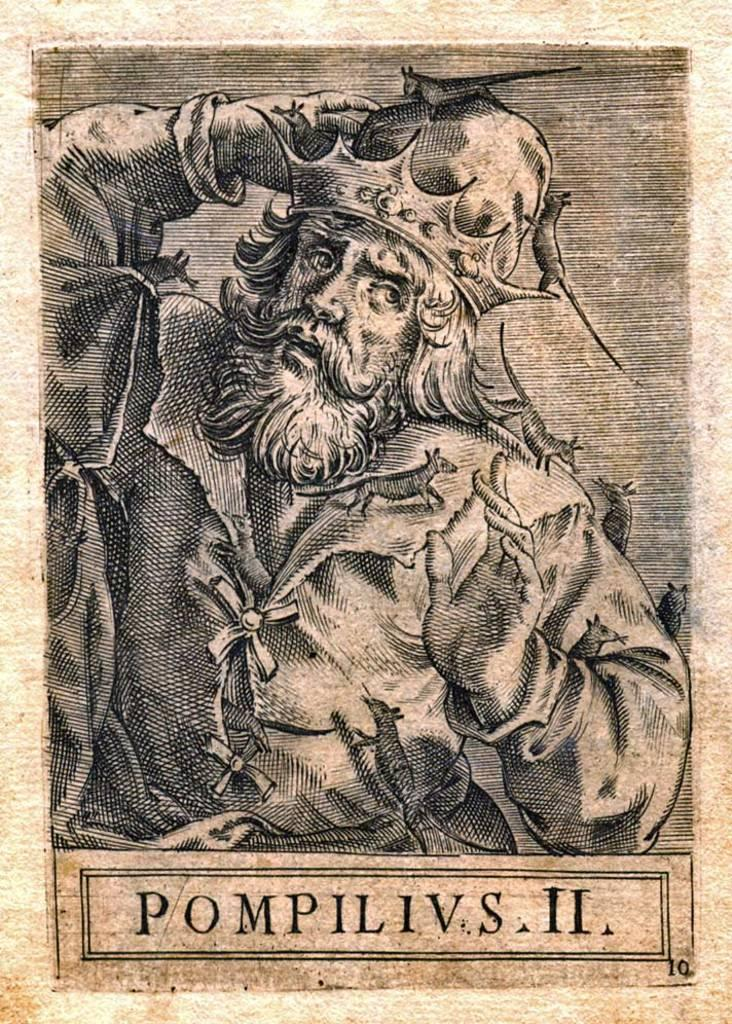<image>
Describe the image concisely. a page from an old text depicting PompIlIVs II in rags with rats crawling on him 